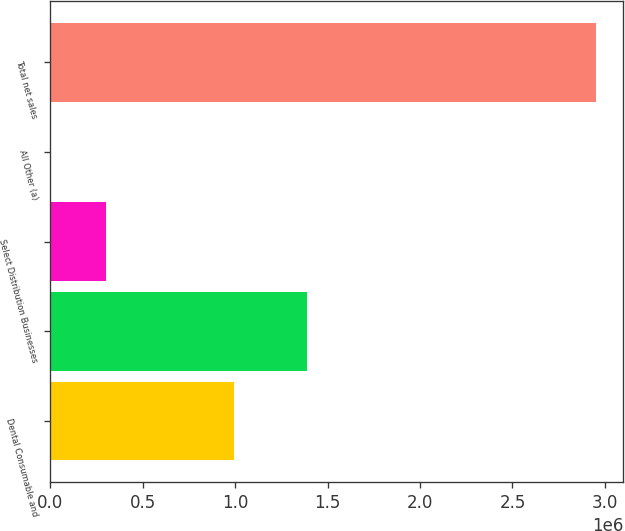Convert chart. <chart><loc_0><loc_0><loc_500><loc_500><bar_chart><fcel>Dental Consumable and<fcel>Unnamed: 1<fcel>Select Distribution Businesses<fcel>All Other (a)<fcel>Total net sales<nl><fcel>991694<fcel>1.38815e+06<fcel>298844<fcel>4185<fcel>2.95077e+06<nl></chart> 